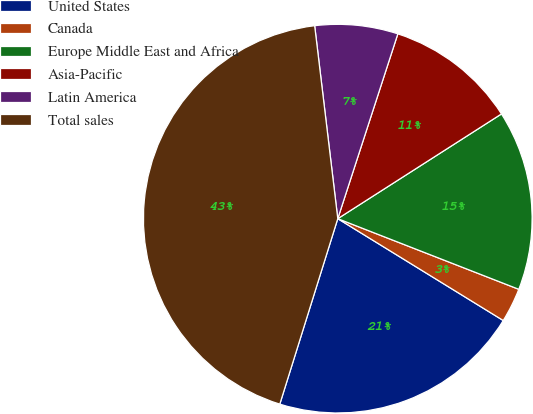Convert chart to OTSL. <chart><loc_0><loc_0><loc_500><loc_500><pie_chart><fcel>United States<fcel>Canada<fcel>Europe Middle East and Africa<fcel>Asia-Pacific<fcel>Latin America<fcel>Total sales<nl><fcel>21.04%<fcel>2.86%<fcel>14.98%<fcel>10.94%<fcel>6.9%<fcel>43.28%<nl></chart> 